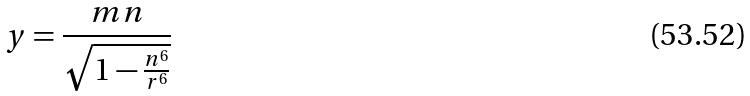<formula> <loc_0><loc_0><loc_500><loc_500>y = \frac { m n } { \sqrt { 1 - \frac { n ^ { 6 } } { r ^ { 6 } } } }</formula> 